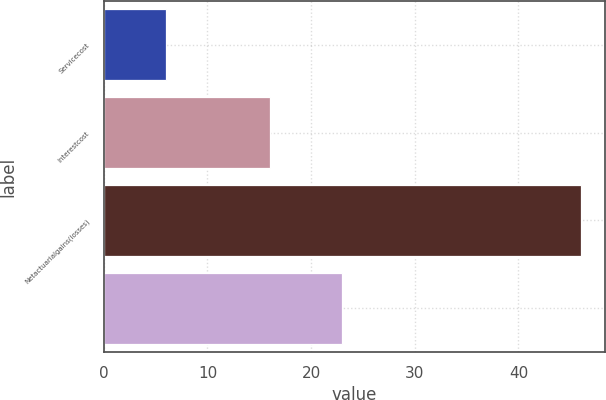<chart> <loc_0><loc_0><loc_500><loc_500><bar_chart><fcel>Servicecost<fcel>Interestcost<fcel>Netactuarialgains(losses)<fcel>Unnamed: 3<nl><fcel>6<fcel>16<fcel>46<fcel>23<nl></chart> 